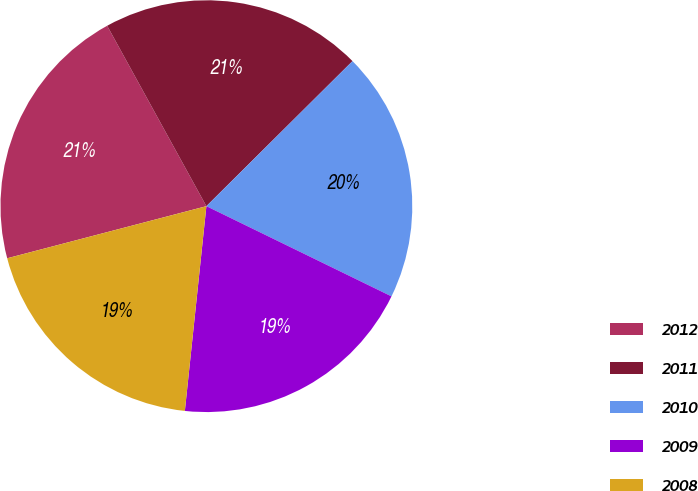Convert chart to OTSL. <chart><loc_0><loc_0><loc_500><loc_500><pie_chart><fcel>2012<fcel>2011<fcel>2010<fcel>2009<fcel>2008<nl><fcel>21.07%<fcel>20.56%<fcel>19.66%<fcel>19.45%<fcel>19.26%<nl></chart> 